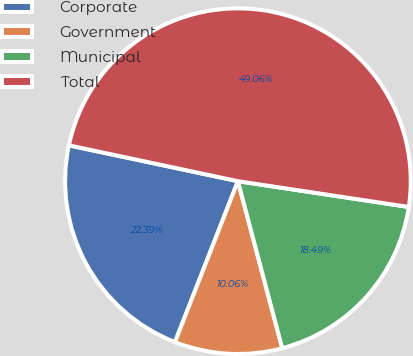Convert chart to OTSL. <chart><loc_0><loc_0><loc_500><loc_500><pie_chart><fcel>Corporate<fcel>Government<fcel>Municipal<fcel>Total<nl><fcel>22.39%<fcel>10.06%<fcel>18.49%<fcel>49.06%<nl></chart> 